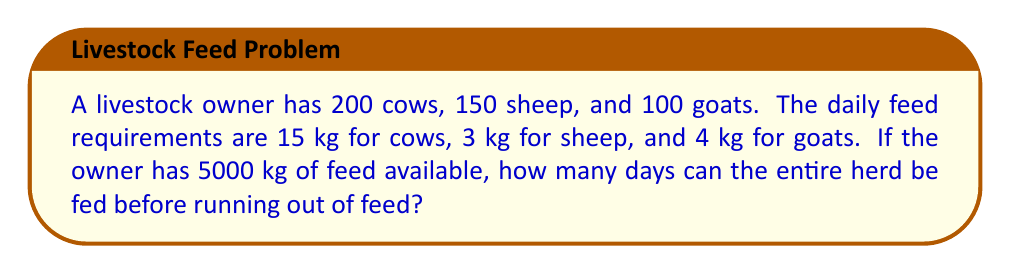Can you solve this math problem? Let's approach this problem step-by-step:

1. Calculate the total daily feed requirement for each animal group:
   - Cows: $200 \times 15 = 3000$ kg
   - Sheep: $150 \times 3 = 450$ kg
   - Goats: $100 \times 4 = 400$ kg

2. Calculate the total daily feed requirement for the entire herd:
   $$ \text{Total daily requirement} = 3000 + 450 + 400 = 3850 \text{ kg} $$

3. To find the number of days the feed will last, divide the total available feed by the daily requirement:
   $$ \text{Number of days} = \frac{\text{Total available feed}}{\text{Total daily requirement}} $$
   $$ \text{Number of days} = \frac{5000 \text{ kg}}{3850 \text{ kg/day}} $$
   $$ \text{Number of days} = 1.2987 \text{ days} $$

4. Since we can't feed partial days, we round down to the nearest whole number:
   $$ \text{Number of full days} = \lfloor 1.2987 \rfloor = 1 \text{ day} $$

Therefore, the livestock owner can feed the entire herd for 1 day before running out of feed.
Answer: 1 day 